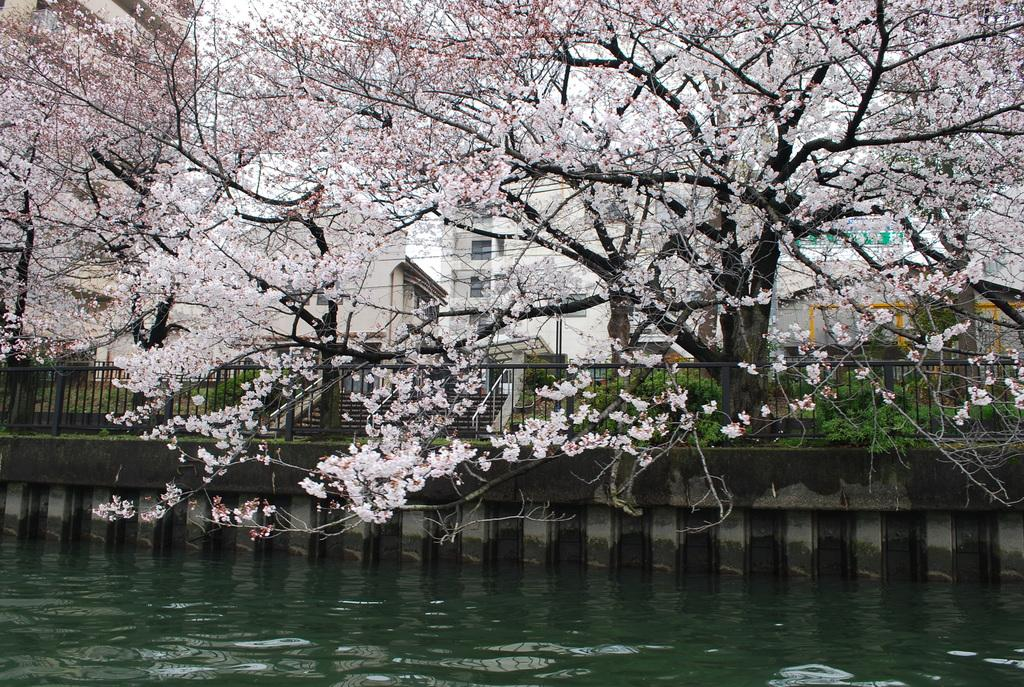What is visible in the image? Water is visible in the image. What can be seen in the background of the image? There are buildings, steps, and trees in the background of the image. What features do the buildings have? The buildings have windows. How many legs can be seen on the water in the image? There are no legs visible in the image, as water does not have legs. 